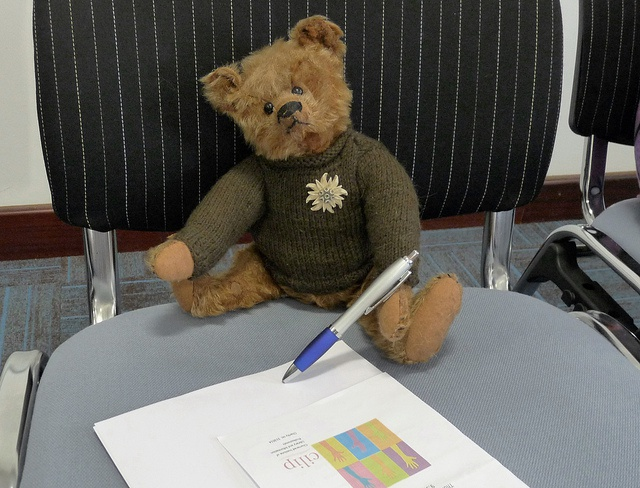Describe the objects in this image and their specific colors. I can see chair in black, darkgray, lightgray, and gray tones, teddy bear in lightgray, black, gray, and olive tones, and chair in lightgray, black, gray, and darkgray tones in this image. 